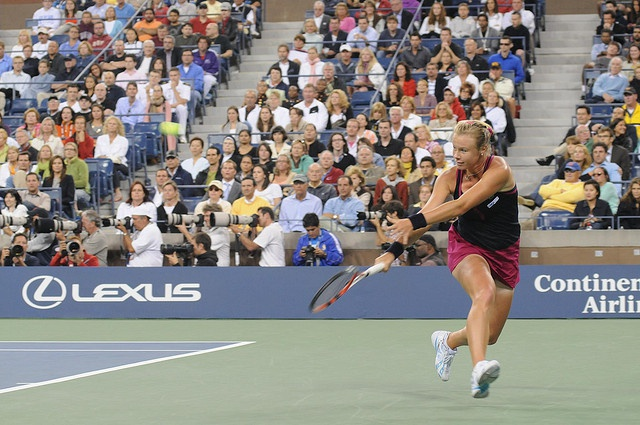Describe the objects in this image and their specific colors. I can see people in gray, darkgray, black, and lightgray tones, people in gray, black, and tan tones, tennis racket in gray, darkgray, and lightgray tones, people in gray, lightgray, and darkgray tones, and people in gray, darkgray, and lavender tones in this image. 